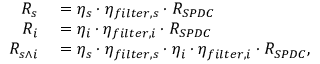<formula> <loc_0><loc_0><loc_500><loc_500>\begin{array} { r l } { R _ { s } } & = \eta _ { s } \cdot \eta _ { f i l t e r , s } \cdot R _ { S P D C } } \\ { R _ { i } } & = \eta _ { i } \cdot \eta _ { f i l t e r , i } \cdot R _ { S P D C } } \\ { R _ { s \wedge i } } & = \eta _ { s } \cdot \eta _ { f i l t e r , s } \cdot \eta _ { i } \cdot \eta _ { f i l t e r , i } \cdot R _ { S P D C } , } \end{array}</formula> 